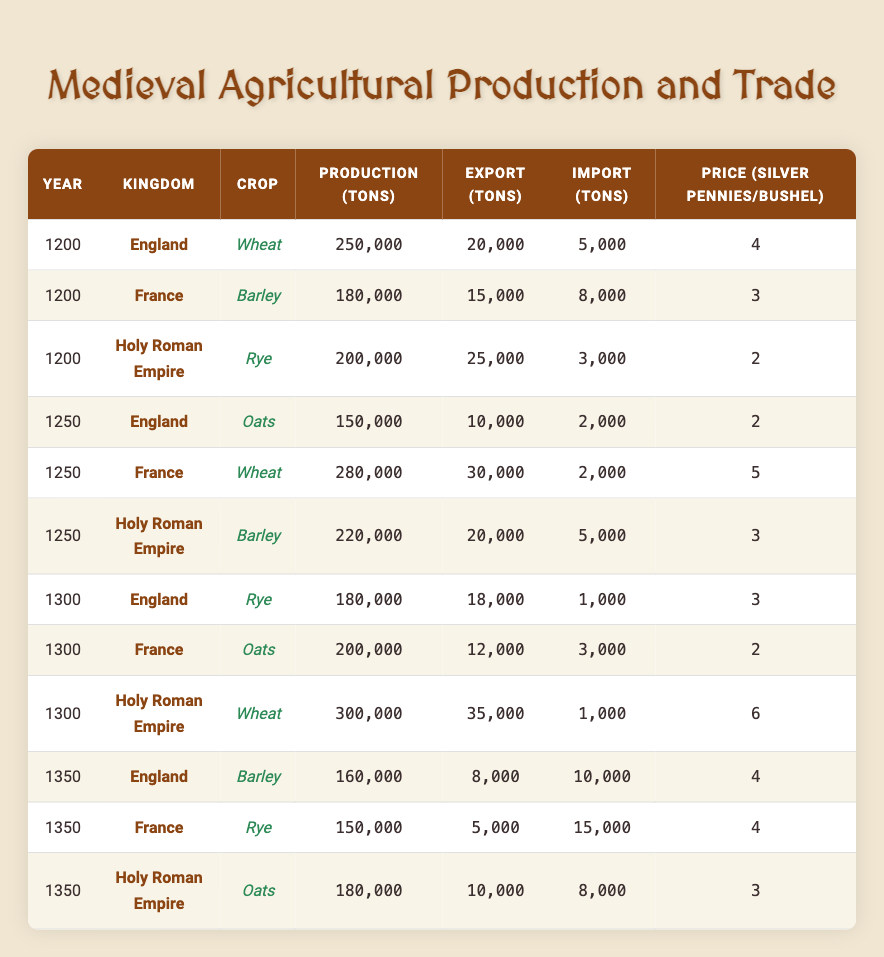What was the production of Wheat in England in the year 1200? In the table, under the year 1200 and kingdom England, the production of Wheat is listed as 250,000 tons.
Answer: 250,000 tons Which crop had the highest production in 1300 among the kingdoms? In the year 1300, the table shows that the Holy Roman Empire produced 300,000 tons of Wheat, which is higher than the production of Rye in England (180,000 tons) and Oats in France (200,000 tons).
Answer: Wheat Did France export more Oats than it imported in the year 1300? In the year 1300, France exported 12,000 tons of Oats and imported 3,000 tons. Since the export quantity is greater than the import quantity, it is true.
Answer: Yes What is the total production of Barley across all kingdoms in the year 1350? In 1350, the production of Barley in England is 160,000 tons, and in the Holy Roman Empire, it is 180,000 tons. Adding these gives a total of 160,000 + 180,000 = 340,000 tons.
Answer: 340,000 tons Was the price of Wheat in the Holy Roman Empire in 1300 higher than the price of Rye in England in 1350? The price of Wheat in the Holy Roman Empire in 1300 is 6 silver pennies per bushel, while the price of Rye in England in 1350 is 4 silver pennies per bushel. Since 6 is greater than 4, the statement is true.
Answer: Yes What is the average production of Oats across the three kingdoms in the year 1250? The production of Oats in 1250 is 150,000 tons in England, 0 tons in France (it was Wheat), and 220,000 tons in the Holy Roman Empire. Calculating the average: (150,000 + 0 + 220,000) / 3 = 136,667 tons.
Answer: 136,667 tons Did any kingdom in the year 1200 import more tons than they exported for their crops? Looking at the year 1200: England exported 20,000 tons and imported 5,000 tons (not more), France exported 15,000 tons and imported 8,000 tons (not more), and the Holy Roman Empire exported 25,000 tons and imported 3,000 tons (not more). None of them imported more than they exported.
Answer: No What was the difference in price per bushel between Wheat in the Holy Roman Empire in 1300 and Barley in England in 1350? The price for Wheat in the Holy Roman Empire in 1300 is 6 silver pennies per bushel, while for Barley in England in 1350, it is 4 silver pennies. Finding the difference: 6 - 4 = 2 silver pennies.
Answer: 2 silver pennies 